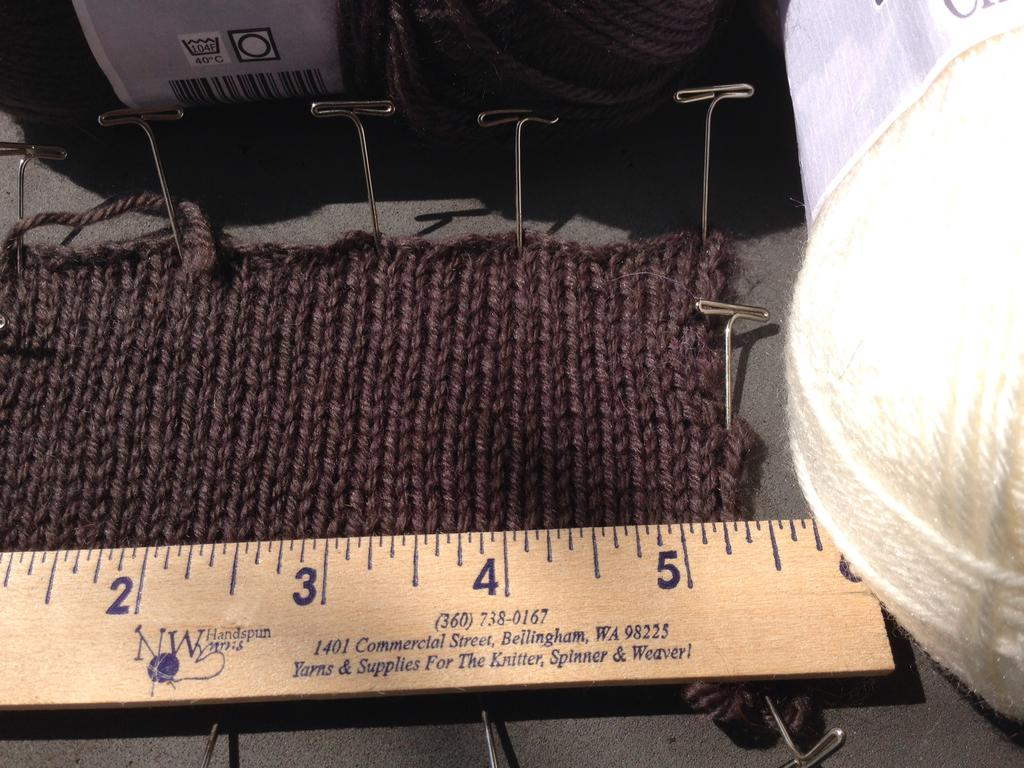<image>
Present a compact description of the photo's key features. Ruler that is on a surface and says the address is in 98225. 